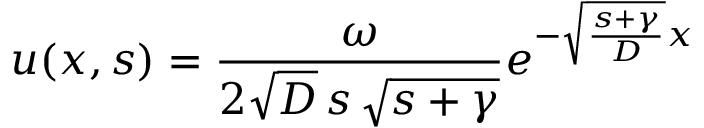<formula> <loc_0><loc_0><loc_500><loc_500>u ( x , s ) = \frac { \omega } { 2 \sqrt { D } \, s \, \sqrt { s + \gamma } } e ^ { - \sqrt { \frac { s + \gamma } { D } } x }</formula> 